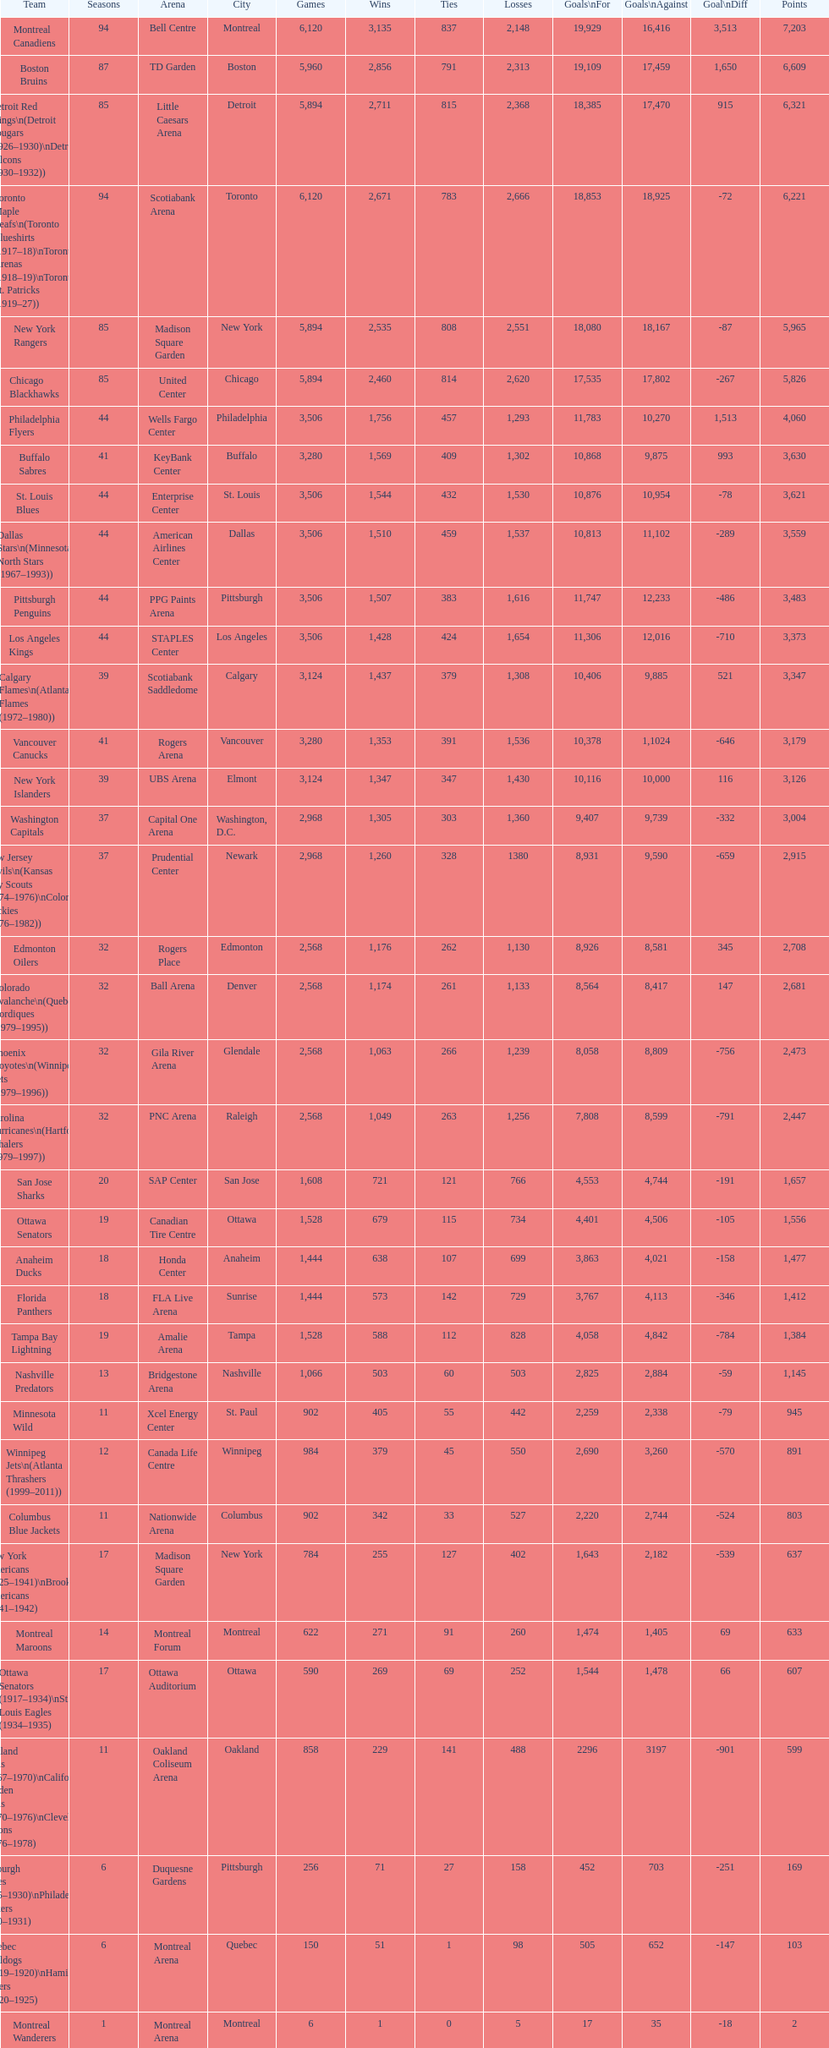How many total points has the lost angeles kings scored? 3,373. 